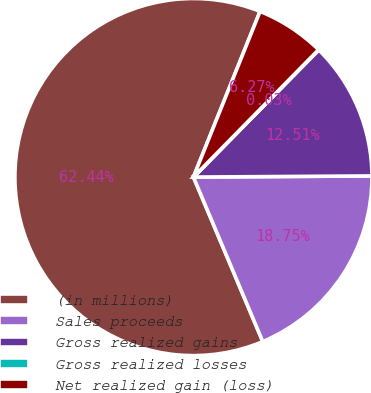Convert chart. <chart><loc_0><loc_0><loc_500><loc_500><pie_chart><fcel>(in millions)<fcel>Sales proceeds<fcel>Gross realized gains<fcel>Gross realized losses<fcel>Net realized gain (loss)<nl><fcel>62.43%<fcel>18.75%<fcel>12.51%<fcel>0.03%<fcel>6.27%<nl></chart> 